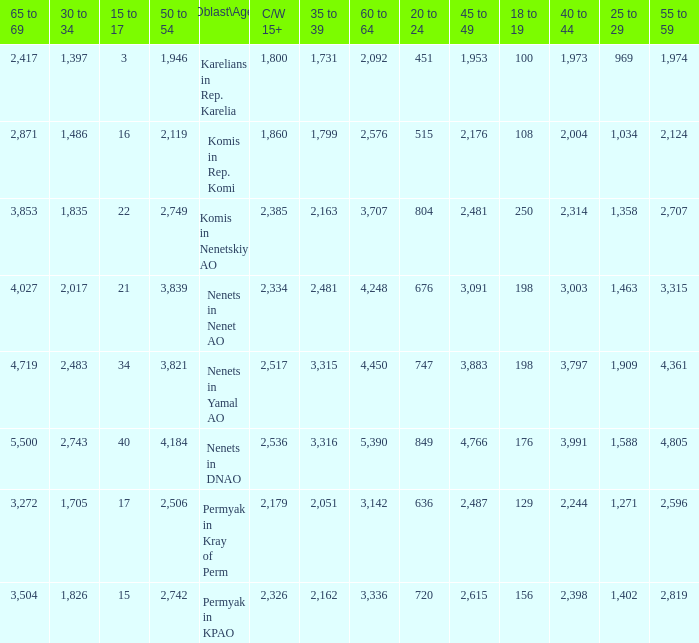What is the mean 55 to 59 when the C/W 15+ is greater than 2,385, and the 30 to 34 is 2,483, and the 35 to 39 is greater than 3,315? None. 